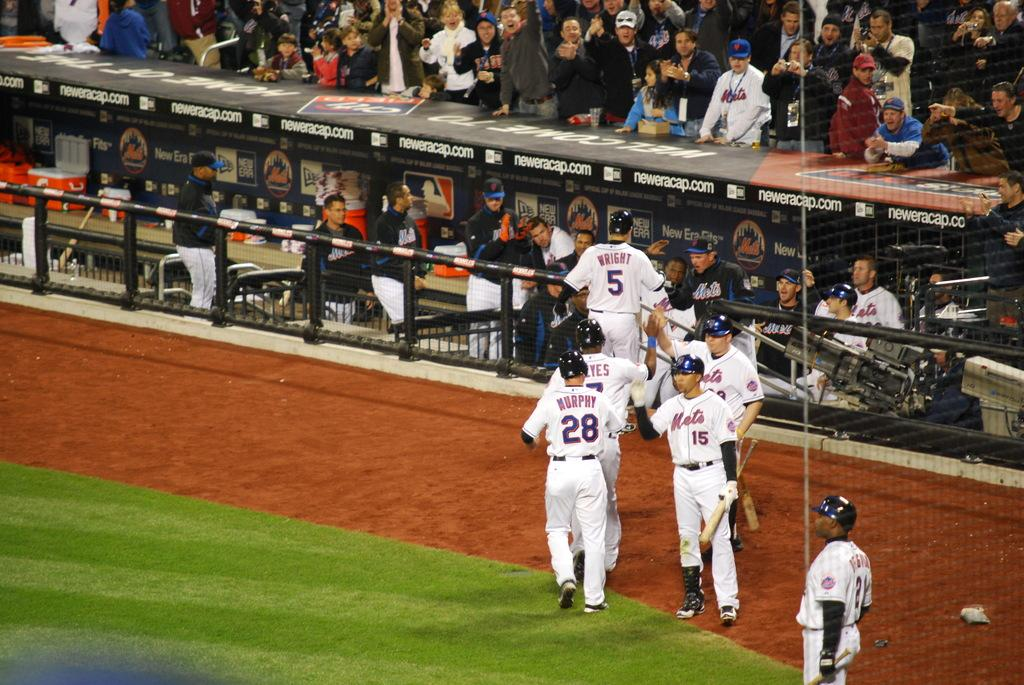<image>
Describe the image concisely. baseball player murpy number 28 running to the sidelines 